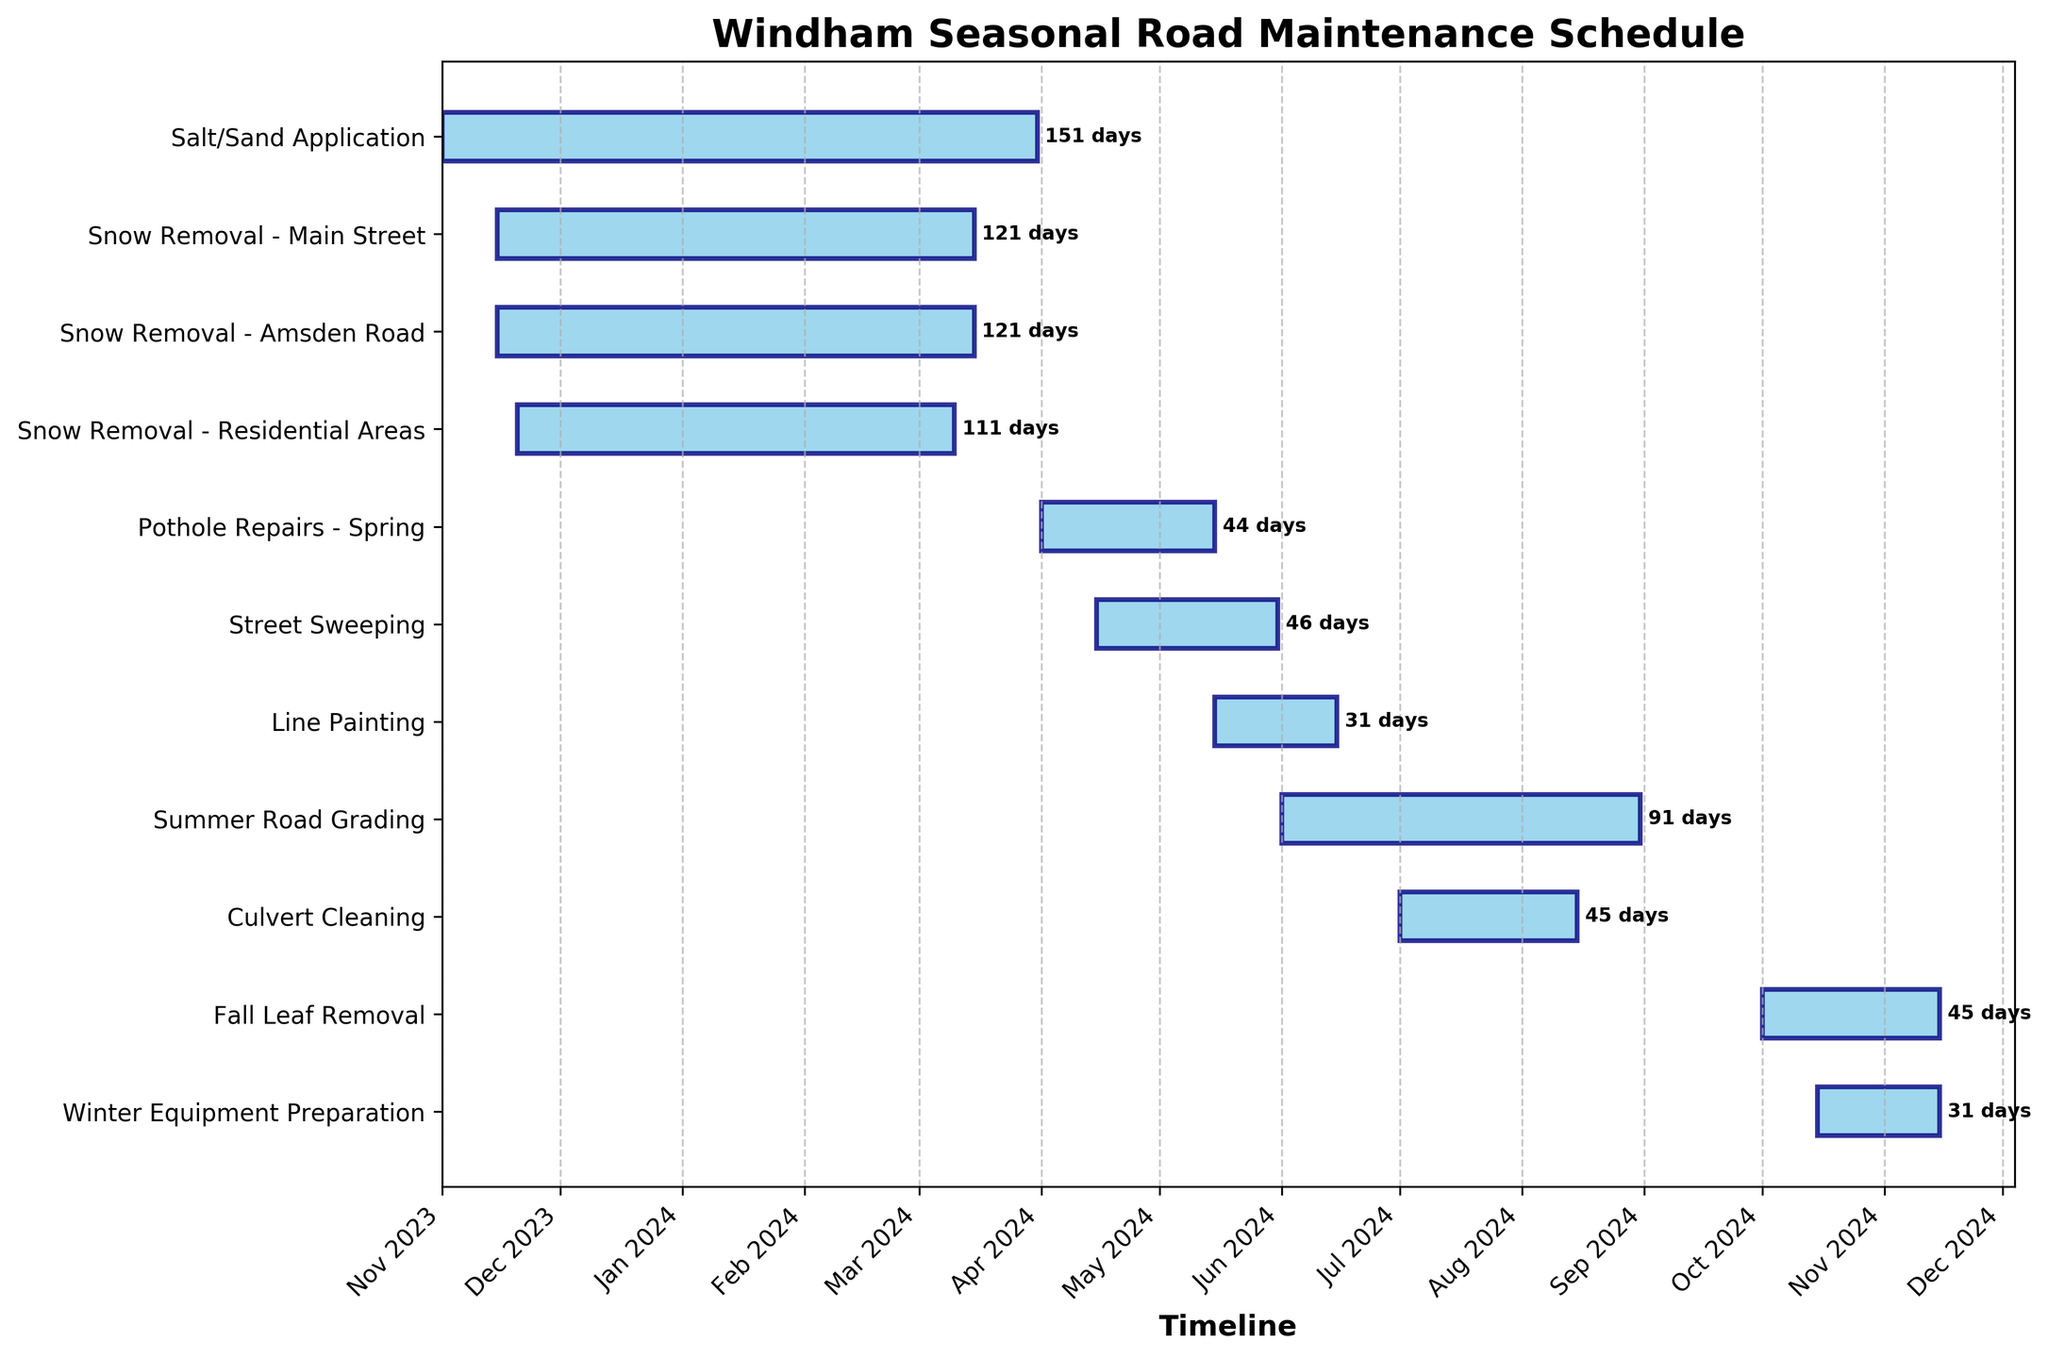What is the title of the Gantt Chart? The title of the chart is displayed prominently at the top and describes what the chart is about.
Answer: Windham Seasonal Road Maintenance Schedule What is the duration for Snow Removal on Main Street? Snow Removal - Main Street starts on 2023-11-15 and ends on 2024-03-15. The duration is the difference between these dates.
Answer: 121 days Which activity ends first in the entire schedule? By looking at the ending dates of all activities, we see that Fall Leaf Removal is the first to end, on 2024-11-15.
Answer: Fall Leaf Removal How many days does the Summer Road Grading last? Summer Road Grading starts on 2024-06-01 and ends on 2024-08-31. The duration is the difference between these dates.
Answer: 92 days What is the gap between the end of Pothole Repairs - Spring and the start of Street Sweeping? Pothole Repairs - Spring ends on 2024-05-15. Street Sweeping starts on 2024-04-15. The gap is calculated by counting the days from 2024-05-15 to 2024-04-15.
Answer: -30 days Which two activities overlap with each other? Overlapping activities are those whose durations fall within the same date ranges. For example, Snow Removal (multiple tasks) and Salt/Sand Application both fall within the period from November to March.
Answer: Snow Removal tasks and Salt/Sand Application When does the task of Line Painting occur, and how long does it last? Line Painting starts on 2024-05-15 and ends on 2024-06-15. The duration is the difference between these dates.
Answer: 31 days How many total days are allocated for Culvert Cleaning? Culvert Cleaning starts on 2024-07-01 and ends on 2024-08-15. The duration is calculated by subtracting the start date from the end date.
Answer: 45 days Which activity is scheduled to start right after the end of Winter Equipment Preparation? Winter Equipment Preparation ends on 2024-11-15. The next scheduled activity is Snow Removal, starting on 2023-11-15.
Answer: Snow Removal What is the total duration of all activities combined? Add up the duration of each individual task: 121 (Main Street) + 121 (Amsden Road) + 111 (Residential Areas) + 151 (Salt/Sand) + 45 (Pothole Repairs) + 46 (Street Sweeping) + 31 (Line Painting) + 92 (Summer Road Grading) + 45 (Culvert Cleaning) + 46 (Fall Leaf Removal) + 31 (Winter Equipment Preparation).
Answer: 840 days 